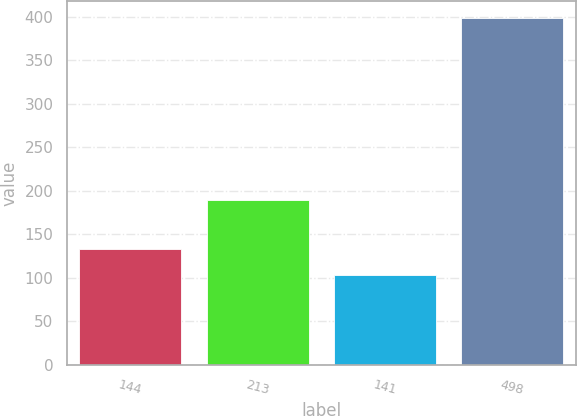<chart> <loc_0><loc_0><loc_500><loc_500><bar_chart><fcel>144<fcel>213<fcel>141<fcel>498<nl><fcel>132.5<fcel>189<fcel>103<fcel>398<nl></chart> 